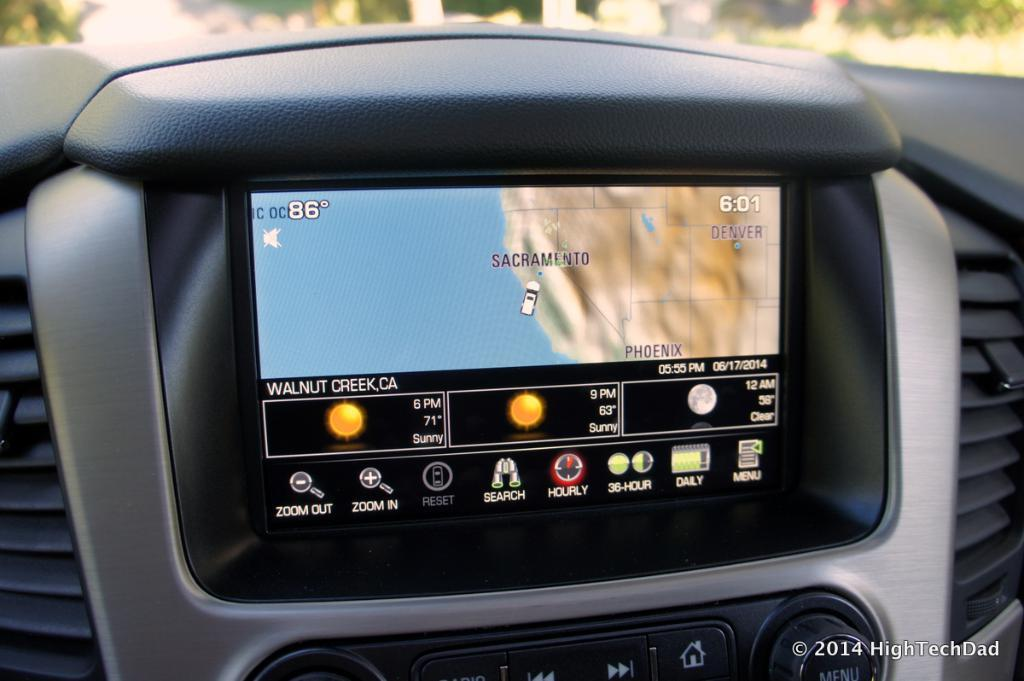What is inside the car that can be seen in the image? There is a screen inside the car. What is displayed on the screen? The screen displays a Google map. How many books are visible on the screen inside the car? There are no books visible on the screen inside the car; it displays a Google map. What type of quilt is covering the seats in the car? There is no quilt present in the image; it only shows a screen displaying a Google map. 